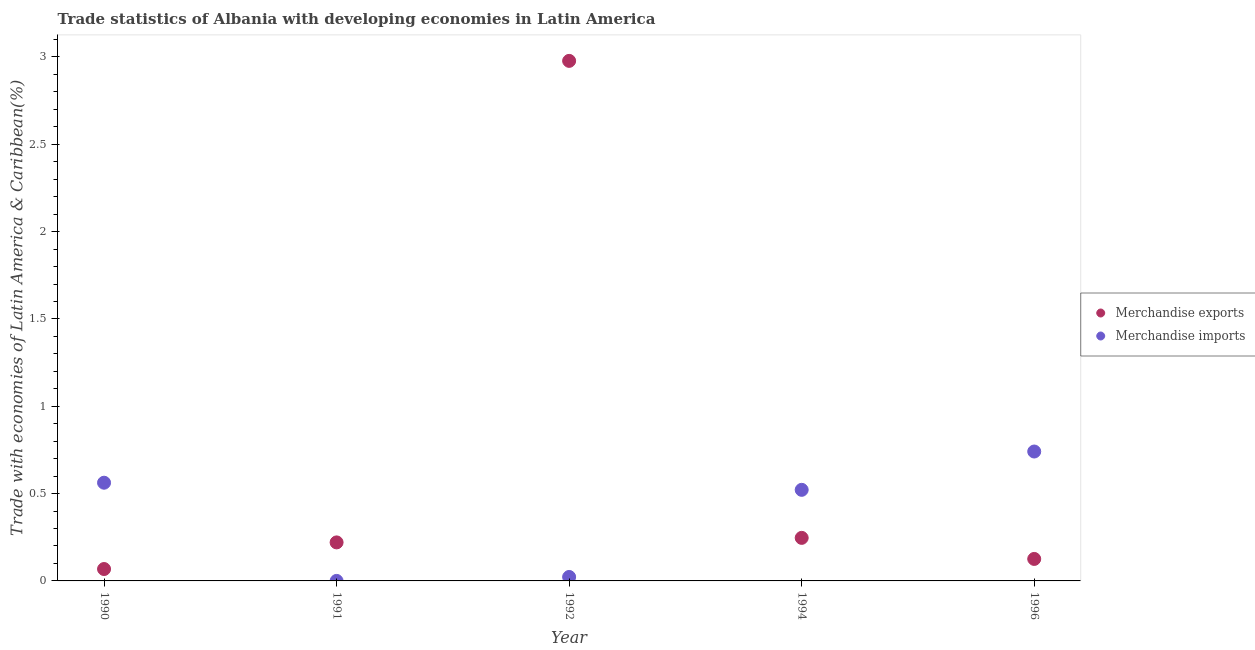Is the number of dotlines equal to the number of legend labels?
Your answer should be compact. Yes. What is the merchandise exports in 1994?
Your response must be concise. 0.25. Across all years, what is the maximum merchandise exports?
Offer a very short reply. 2.98. Across all years, what is the minimum merchandise exports?
Give a very brief answer. 0.07. In which year was the merchandise imports minimum?
Your answer should be compact. 1991. What is the total merchandise exports in the graph?
Offer a very short reply. 3.64. What is the difference between the merchandise exports in 1990 and that in 1994?
Offer a very short reply. -0.18. What is the difference between the merchandise exports in 1996 and the merchandise imports in 1991?
Keep it short and to the point. 0.13. What is the average merchandise imports per year?
Provide a succinct answer. 0.37. In the year 1991, what is the difference between the merchandise exports and merchandise imports?
Your response must be concise. 0.22. In how many years, is the merchandise exports greater than 0.8 %?
Ensure brevity in your answer.  1. What is the ratio of the merchandise exports in 1991 to that in 1992?
Offer a terse response. 0.07. Is the merchandise exports in 1992 less than that in 1996?
Provide a succinct answer. No. Is the difference between the merchandise imports in 1992 and 1996 greater than the difference between the merchandise exports in 1992 and 1996?
Give a very brief answer. No. What is the difference between the highest and the second highest merchandise exports?
Provide a succinct answer. 2.73. What is the difference between the highest and the lowest merchandise exports?
Offer a very short reply. 2.91. How many dotlines are there?
Make the answer very short. 2. How many years are there in the graph?
Provide a succinct answer. 5. Are the values on the major ticks of Y-axis written in scientific E-notation?
Your response must be concise. No. Does the graph contain grids?
Your answer should be very brief. No. How many legend labels are there?
Your answer should be compact. 2. What is the title of the graph?
Keep it short and to the point. Trade statistics of Albania with developing economies in Latin America. What is the label or title of the X-axis?
Your answer should be very brief. Year. What is the label or title of the Y-axis?
Provide a succinct answer. Trade with economies of Latin America & Caribbean(%). What is the Trade with economies of Latin America & Caribbean(%) in Merchandise exports in 1990?
Offer a very short reply. 0.07. What is the Trade with economies of Latin America & Caribbean(%) of Merchandise imports in 1990?
Provide a succinct answer. 0.56. What is the Trade with economies of Latin America & Caribbean(%) in Merchandise exports in 1991?
Provide a succinct answer. 0.22. What is the Trade with economies of Latin America & Caribbean(%) of Merchandise imports in 1991?
Your answer should be compact. 6.82564304270047e-5. What is the Trade with economies of Latin America & Caribbean(%) in Merchandise exports in 1992?
Ensure brevity in your answer.  2.98. What is the Trade with economies of Latin America & Caribbean(%) in Merchandise imports in 1992?
Ensure brevity in your answer.  0.02. What is the Trade with economies of Latin America & Caribbean(%) in Merchandise exports in 1994?
Give a very brief answer. 0.25. What is the Trade with economies of Latin America & Caribbean(%) of Merchandise imports in 1994?
Provide a short and direct response. 0.52. What is the Trade with economies of Latin America & Caribbean(%) in Merchandise exports in 1996?
Your response must be concise. 0.13. What is the Trade with economies of Latin America & Caribbean(%) in Merchandise imports in 1996?
Your response must be concise. 0.74. Across all years, what is the maximum Trade with economies of Latin America & Caribbean(%) in Merchandise exports?
Offer a terse response. 2.98. Across all years, what is the maximum Trade with economies of Latin America & Caribbean(%) of Merchandise imports?
Your answer should be very brief. 0.74. Across all years, what is the minimum Trade with economies of Latin America & Caribbean(%) in Merchandise exports?
Offer a terse response. 0.07. Across all years, what is the minimum Trade with economies of Latin America & Caribbean(%) of Merchandise imports?
Your answer should be very brief. 6.82564304270047e-5. What is the total Trade with economies of Latin America & Caribbean(%) in Merchandise exports in the graph?
Your answer should be compact. 3.64. What is the total Trade with economies of Latin America & Caribbean(%) of Merchandise imports in the graph?
Provide a short and direct response. 1.85. What is the difference between the Trade with economies of Latin America & Caribbean(%) of Merchandise exports in 1990 and that in 1991?
Offer a very short reply. -0.15. What is the difference between the Trade with economies of Latin America & Caribbean(%) in Merchandise imports in 1990 and that in 1991?
Give a very brief answer. 0.56. What is the difference between the Trade with economies of Latin America & Caribbean(%) of Merchandise exports in 1990 and that in 1992?
Your response must be concise. -2.91. What is the difference between the Trade with economies of Latin America & Caribbean(%) of Merchandise imports in 1990 and that in 1992?
Provide a short and direct response. 0.54. What is the difference between the Trade with economies of Latin America & Caribbean(%) of Merchandise exports in 1990 and that in 1994?
Make the answer very short. -0.18. What is the difference between the Trade with economies of Latin America & Caribbean(%) in Merchandise imports in 1990 and that in 1994?
Provide a short and direct response. 0.04. What is the difference between the Trade with economies of Latin America & Caribbean(%) in Merchandise exports in 1990 and that in 1996?
Give a very brief answer. -0.06. What is the difference between the Trade with economies of Latin America & Caribbean(%) of Merchandise imports in 1990 and that in 1996?
Offer a very short reply. -0.18. What is the difference between the Trade with economies of Latin America & Caribbean(%) of Merchandise exports in 1991 and that in 1992?
Provide a short and direct response. -2.76. What is the difference between the Trade with economies of Latin America & Caribbean(%) in Merchandise imports in 1991 and that in 1992?
Your answer should be very brief. -0.02. What is the difference between the Trade with economies of Latin America & Caribbean(%) of Merchandise exports in 1991 and that in 1994?
Offer a very short reply. -0.03. What is the difference between the Trade with economies of Latin America & Caribbean(%) in Merchandise imports in 1991 and that in 1994?
Make the answer very short. -0.52. What is the difference between the Trade with economies of Latin America & Caribbean(%) in Merchandise exports in 1991 and that in 1996?
Your response must be concise. 0.09. What is the difference between the Trade with economies of Latin America & Caribbean(%) in Merchandise imports in 1991 and that in 1996?
Keep it short and to the point. -0.74. What is the difference between the Trade with economies of Latin America & Caribbean(%) of Merchandise exports in 1992 and that in 1994?
Offer a very short reply. 2.73. What is the difference between the Trade with economies of Latin America & Caribbean(%) of Merchandise imports in 1992 and that in 1994?
Your answer should be very brief. -0.5. What is the difference between the Trade with economies of Latin America & Caribbean(%) in Merchandise exports in 1992 and that in 1996?
Offer a very short reply. 2.85. What is the difference between the Trade with economies of Latin America & Caribbean(%) of Merchandise imports in 1992 and that in 1996?
Give a very brief answer. -0.72. What is the difference between the Trade with economies of Latin America & Caribbean(%) in Merchandise exports in 1994 and that in 1996?
Offer a terse response. 0.12. What is the difference between the Trade with economies of Latin America & Caribbean(%) in Merchandise imports in 1994 and that in 1996?
Offer a very short reply. -0.22. What is the difference between the Trade with economies of Latin America & Caribbean(%) in Merchandise exports in 1990 and the Trade with economies of Latin America & Caribbean(%) in Merchandise imports in 1991?
Provide a short and direct response. 0.07. What is the difference between the Trade with economies of Latin America & Caribbean(%) of Merchandise exports in 1990 and the Trade with economies of Latin America & Caribbean(%) of Merchandise imports in 1992?
Your response must be concise. 0.05. What is the difference between the Trade with economies of Latin America & Caribbean(%) of Merchandise exports in 1990 and the Trade with economies of Latin America & Caribbean(%) of Merchandise imports in 1994?
Provide a short and direct response. -0.45. What is the difference between the Trade with economies of Latin America & Caribbean(%) of Merchandise exports in 1990 and the Trade with economies of Latin America & Caribbean(%) of Merchandise imports in 1996?
Your answer should be very brief. -0.67. What is the difference between the Trade with economies of Latin America & Caribbean(%) in Merchandise exports in 1991 and the Trade with economies of Latin America & Caribbean(%) in Merchandise imports in 1992?
Offer a very short reply. 0.2. What is the difference between the Trade with economies of Latin America & Caribbean(%) of Merchandise exports in 1991 and the Trade with economies of Latin America & Caribbean(%) of Merchandise imports in 1994?
Provide a succinct answer. -0.3. What is the difference between the Trade with economies of Latin America & Caribbean(%) of Merchandise exports in 1991 and the Trade with economies of Latin America & Caribbean(%) of Merchandise imports in 1996?
Offer a terse response. -0.52. What is the difference between the Trade with economies of Latin America & Caribbean(%) in Merchandise exports in 1992 and the Trade with economies of Latin America & Caribbean(%) in Merchandise imports in 1994?
Your answer should be compact. 2.46. What is the difference between the Trade with economies of Latin America & Caribbean(%) of Merchandise exports in 1992 and the Trade with economies of Latin America & Caribbean(%) of Merchandise imports in 1996?
Your response must be concise. 2.24. What is the difference between the Trade with economies of Latin America & Caribbean(%) of Merchandise exports in 1994 and the Trade with economies of Latin America & Caribbean(%) of Merchandise imports in 1996?
Ensure brevity in your answer.  -0.49. What is the average Trade with economies of Latin America & Caribbean(%) of Merchandise exports per year?
Your answer should be very brief. 0.73. What is the average Trade with economies of Latin America & Caribbean(%) in Merchandise imports per year?
Offer a very short reply. 0.37. In the year 1990, what is the difference between the Trade with economies of Latin America & Caribbean(%) of Merchandise exports and Trade with economies of Latin America & Caribbean(%) of Merchandise imports?
Your response must be concise. -0.49. In the year 1991, what is the difference between the Trade with economies of Latin America & Caribbean(%) of Merchandise exports and Trade with economies of Latin America & Caribbean(%) of Merchandise imports?
Ensure brevity in your answer.  0.22. In the year 1992, what is the difference between the Trade with economies of Latin America & Caribbean(%) in Merchandise exports and Trade with economies of Latin America & Caribbean(%) in Merchandise imports?
Ensure brevity in your answer.  2.96. In the year 1994, what is the difference between the Trade with economies of Latin America & Caribbean(%) in Merchandise exports and Trade with economies of Latin America & Caribbean(%) in Merchandise imports?
Your answer should be compact. -0.28. In the year 1996, what is the difference between the Trade with economies of Latin America & Caribbean(%) of Merchandise exports and Trade with economies of Latin America & Caribbean(%) of Merchandise imports?
Make the answer very short. -0.62. What is the ratio of the Trade with economies of Latin America & Caribbean(%) in Merchandise exports in 1990 to that in 1991?
Your answer should be very brief. 0.31. What is the ratio of the Trade with economies of Latin America & Caribbean(%) in Merchandise imports in 1990 to that in 1991?
Your answer should be compact. 8238.29. What is the ratio of the Trade with economies of Latin America & Caribbean(%) of Merchandise exports in 1990 to that in 1992?
Make the answer very short. 0.02. What is the ratio of the Trade with economies of Latin America & Caribbean(%) of Merchandise imports in 1990 to that in 1992?
Offer a very short reply. 24.84. What is the ratio of the Trade with economies of Latin America & Caribbean(%) of Merchandise exports in 1990 to that in 1994?
Your response must be concise. 0.28. What is the ratio of the Trade with economies of Latin America & Caribbean(%) of Merchandise imports in 1990 to that in 1994?
Ensure brevity in your answer.  1.08. What is the ratio of the Trade with economies of Latin America & Caribbean(%) of Merchandise exports in 1990 to that in 1996?
Offer a terse response. 0.54. What is the ratio of the Trade with economies of Latin America & Caribbean(%) in Merchandise imports in 1990 to that in 1996?
Give a very brief answer. 0.76. What is the ratio of the Trade with economies of Latin America & Caribbean(%) of Merchandise exports in 1991 to that in 1992?
Offer a very short reply. 0.07. What is the ratio of the Trade with economies of Latin America & Caribbean(%) of Merchandise imports in 1991 to that in 1992?
Make the answer very short. 0. What is the ratio of the Trade with economies of Latin America & Caribbean(%) of Merchandise exports in 1991 to that in 1994?
Offer a very short reply. 0.89. What is the ratio of the Trade with economies of Latin America & Caribbean(%) in Merchandise imports in 1991 to that in 1994?
Provide a succinct answer. 0. What is the ratio of the Trade with economies of Latin America & Caribbean(%) in Merchandise exports in 1991 to that in 1996?
Your response must be concise. 1.75. What is the ratio of the Trade with economies of Latin America & Caribbean(%) of Merchandise exports in 1992 to that in 1994?
Make the answer very short. 12.08. What is the ratio of the Trade with economies of Latin America & Caribbean(%) of Merchandise imports in 1992 to that in 1994?
Offer a terse response. 0.04. What is the ratio of the Trade with economies of Latin America & Caribbean(%) in Merchandise exports in 1992 to that in 1996?
Provide a short and direct response. 23.65. What is the ratio of the Trade with economies of Latin America & Caribbean(%) of Merchandise imports in 1992 to that in 1996?
Your response must be concise. 0.03. What is the ratio of the Trade with economies of Latin America & Caribbean(%) of Merchandise exports in 1994 to that in 1996?
Offer a terse response. 1.96. What is the ratio of the Trade with economies of Latin America & Caribbean(%) of Merchandise imports in 1994 to that in 1996?
Your response must be concise. 0.7. What is the difference between the highest and the second highest Trade with economies of Latin America & Caribbean(%) in Merchandise exports?
Your answer should be compact. 2.73. What is the difference between the highest and the second highest Trade with economies of Latin America & Caribbean(%) of Merchandise imports?
Make the answer very short. 0.18. What is the difference between the highest and the lowest Trade with economies of Latin America & Caribbean(%) in Merchandise exports?
Offer a terse response. 2.91. What is the difference between the highest and the lowest Trade with economies of Latin America & Caribbean(%) of Merchandise imports?
Ensure brevity in your answer.  0.74. 